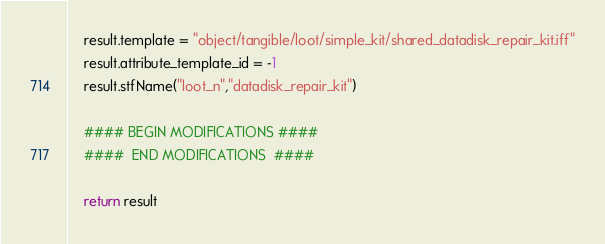<code> <loc_0><loc_0><loc_500><loc_500><_Python_>	result.template = "object/tangible/loot/simple_kit/shared_datadisk_repair_kit.iff"
	result.attribute_template_id = -1
	result.stfName("loot_n","datadisk_repair_kit")		
	
	#### BEGIN MODIFICATIONS ####
	####  END MODIFICATIONS  ####
	
	return result</code> 